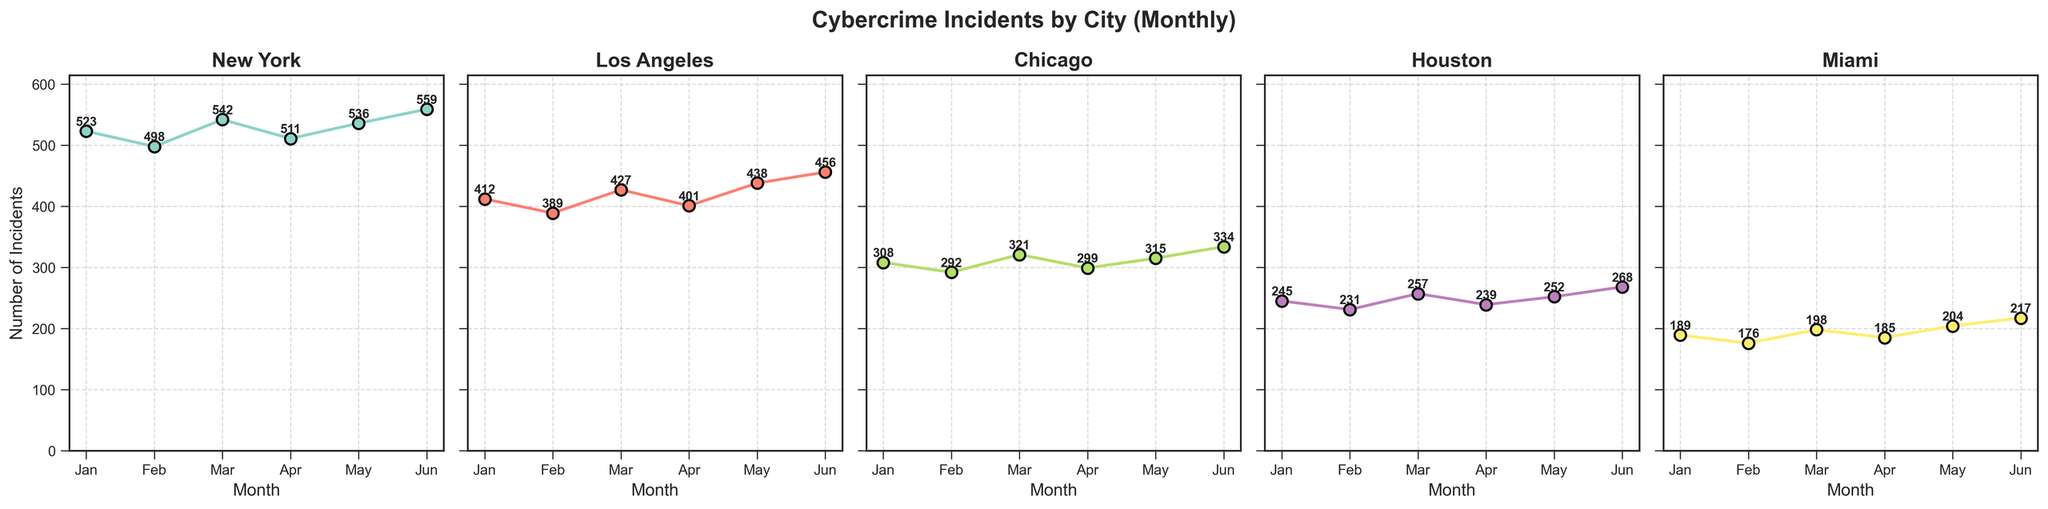What month had the highest number of cybercrime incidents in Los Angeles? Look for the month with the highest point on Los Angeles' subplot. The highest data point is around 456 incidents in June.
Answer: June Which city reported the lowest number of incidents in January? Compare the data points for January across all cities. Miami has the lowest data point for January with 189 incidents.
Answer: Miami What's the difference in the number of incidents between March and May in Chicago? Find the data points for March and May in Chicago. In March, there are 321 incidents and in May, there are 315. Subtracting May from March gives 321 - 315 = 6.
Answer: 6 Which city showed the largest increase in cybercrime incidents between February and June? Calculate the increase for each city from February to June. New York increased from 498 to 559 (increase of 61), Los Angeles from 389 to 456 (increase of 67), Chicago from 292 to 334 (increase of 42), Houston from 231 to 268 (increase of 37), and Miami from 176 to 217 (increase of 41). Los Angeles has the largest increase.
Answer: Los Angeles How many incidents were reported in New York and Miami combined for the month of March? Sum the incidents for New York and Miami in March. New York has 542 incidents and Miami has 198 incidents. The combined total is 542 + 198 = 740.
Answer: 740 In which city did the number of incidents consistently increase from January to June? Observe each subplot to see if the incidents increase every month. Miami's incidents go from 189 (Jan), 176 (Feb), 198 (Mar), 185 (Apr), 204 (May), to 217 (Jun). Miami shows a consistent increase.
Answer: Miami In which month did Houston report fewer incidents than Chicago but more than Miami? Compare Houston's incidents with Chicago's and Miami's incidents month-by-month. In April, Houston reported 239 incidents, which is fewer than Chicago's 299 but more than Miami's 185 incidents.
Answer: April What's the average number of incidents reported in Los Angeles over the six months? Add up the incidents for Los Angeles from January to June and divide by 6. (412 + 389 + 427 + 401 + 438 + 456) / 6 = 2523 / 6 = 420.5
Answer: 420.5 Between New York and Chicago, which city has a higher median number of incidents for the first half of the year? Identify the median value for six months' data for both New York and Chicago. For New York, the values are 523, 498, 542, 511, 536, 559; the median is (523 + 536) / 2 = 529.5. For Chicago, the values are 308, 292, 321, 299, 315, 334; the median is (308 + 315) / 2 = 311.5. New York has a higher median.
Answer: New York Which city had the most significant fluctuation in the number of incidents between consecutive months? Identify the largest month-to-month differences for each city. Compare those differences: New York: 44 (Mar-Apr), Los Angeles: 41 (May-Jun), Chicago: 29 (Feb-Mar), Houston: 26 (Feb-Mar), Miami: 22 (Feb-Mar). New York had the most significant fluctuation.
Answer: New York 